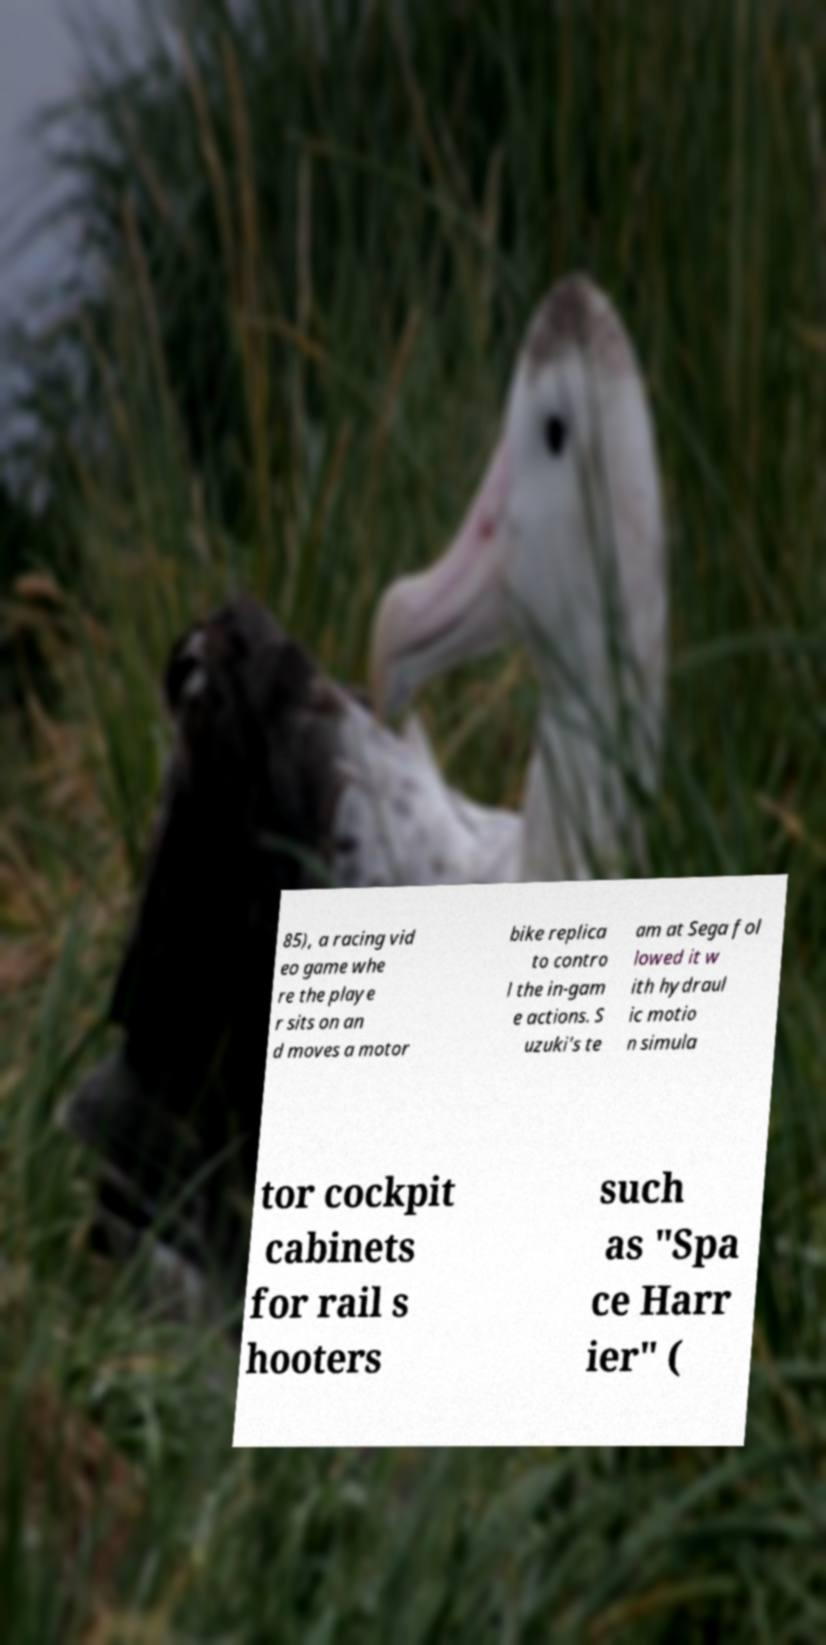Could you extract and type out the text from this image? 85), a racing vid eo game whe re the playe r sits on an d moves a motor bike replica to contro l the in-gam e actions. S uzuki's te am at Sega fol lowed it w ith hydraul ic motio n simula tor cockpit cabinets for rail s hooters such as "Spa ce Harr ier" ( 